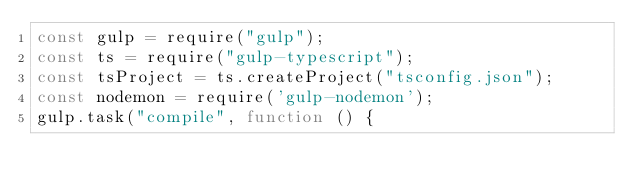<code> <loc_0><loc_0><loc_500><loc_500><_JavaScript_>const gulp = require("gulp");
const ts = require("gulp-typescript");
const tsProject = ts.createProject("tsconfig.json");
const nodemon = require('gulp-nodemon');
gulp.task("compile", function () {</code> 